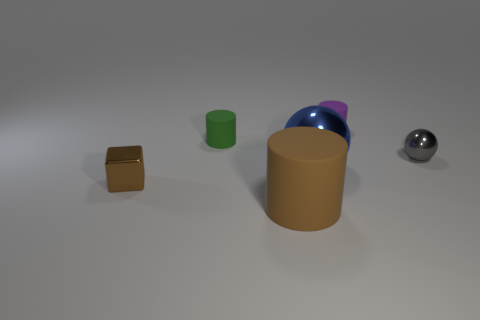There is a gray sphere that is the same material as the brown cube; what is its size?
Offer a terse response. Small. How many purple rubber objects are the same shape as the large blue thing?
Your answer should be very brief. 0. Is there any other thing that is the same size as the brown cylinder?
Give a very brief answer. Yes. What is the size of the sphere on the left side of the cylinder behind the tiny green cylinder?
Keep it short and to the point. Large. There is a thing that is the same size as the brown cylinder; what is it made of?
Your answer should be compact. Metal. Is there a small cube that has the same material as the brown cylinder?
Offer a very short reply. No. What color is the cylinder in front of the brown object to the left of the cylinder in front of the tiny ball?
Your response must be concise. Brown. Does the large object in front of the tiny brown cube have the same color as the large object that is behind the tiny brown metal thing?
Your answer should be compact. No. Are there any other things that are the same color as the tiny block?
Ensure brevity in your answer.  Yes. Is the number of green cylinders that are in front of the green matte thing less than the number of small purple rubber things?
Provide a short and direct response. Yes. 